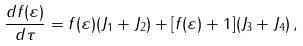<formula> <loc_0><loc_0><loc_500><loc_500>\frac { d f ( \varepsilon ) } { d \tau } = f ( \varepsilon ) ( J _ { 1 } + J _ { 2 } ) + [ f ( \varepsilon ) + 1 ] ( J _ { 3 } + J _ { 4 } ) \, ,</formula> 